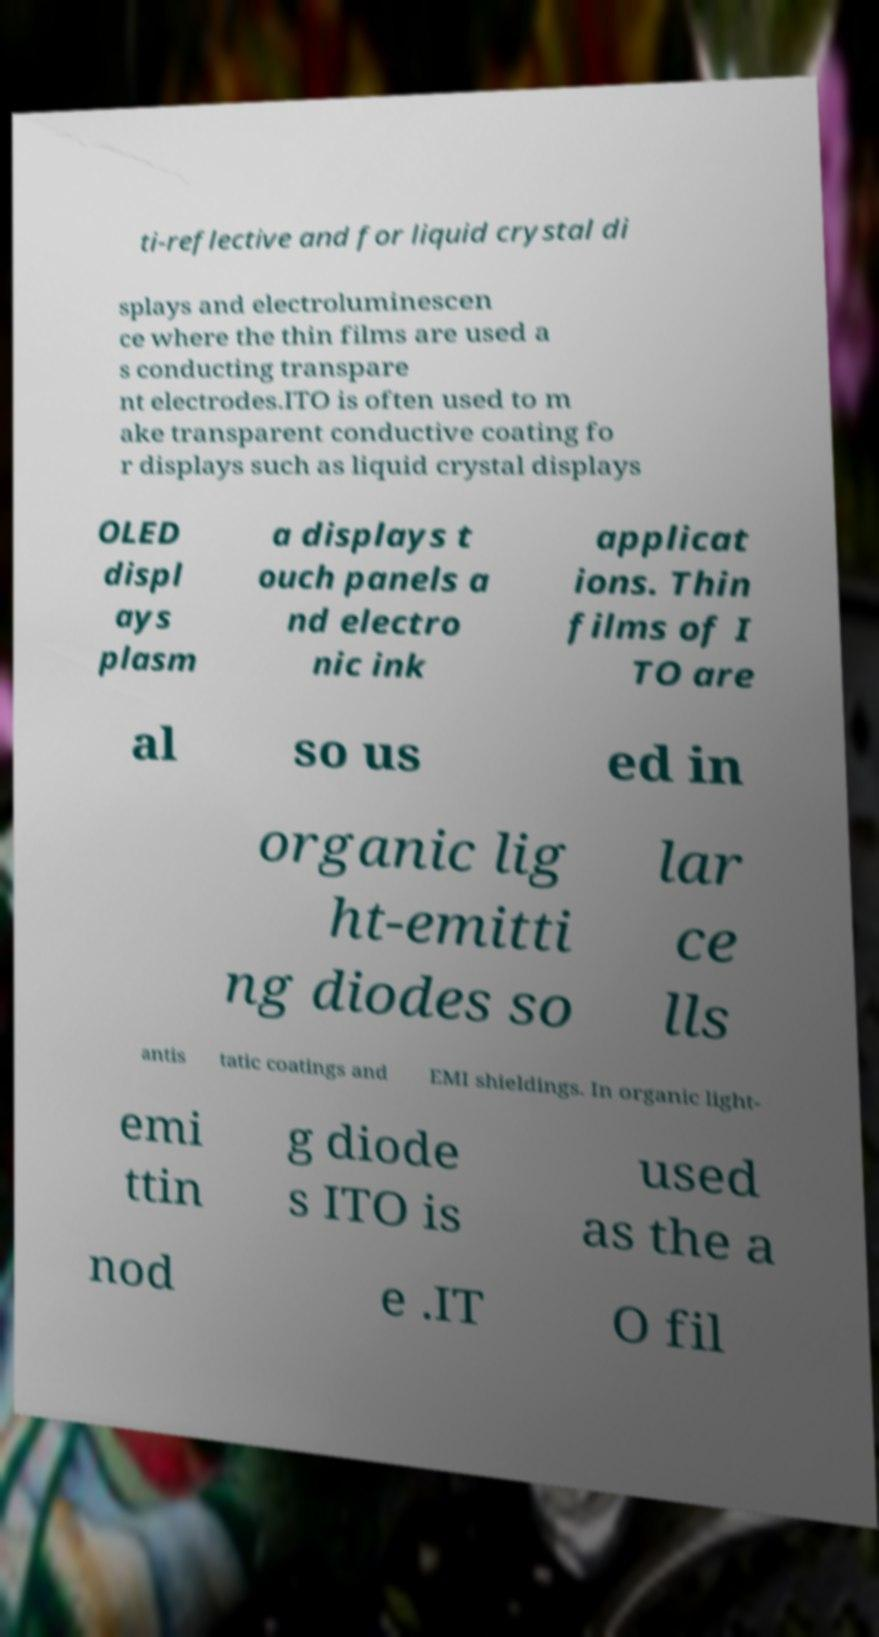Please read and relay the text visible in this image. What does it say? ti-reflective and for liquid crystal di splays and electroluminescen ce where the thin films are used a s conducting transpare nt electrodes.ITO is often used to m ake transparent conductive coating fo r displays such as liquid crystal displays OLED displ ays plasm a displays t ouch panels a nd electro nic ink applicat ions. Thin films of I TO are al so us ed in organic lig ht-emitti ng diodes so lar ce lls antis tatic coatings and EMI shieldings. In organic light- emi ttin g diode s ITO is used as the a nod e .IT O fil 